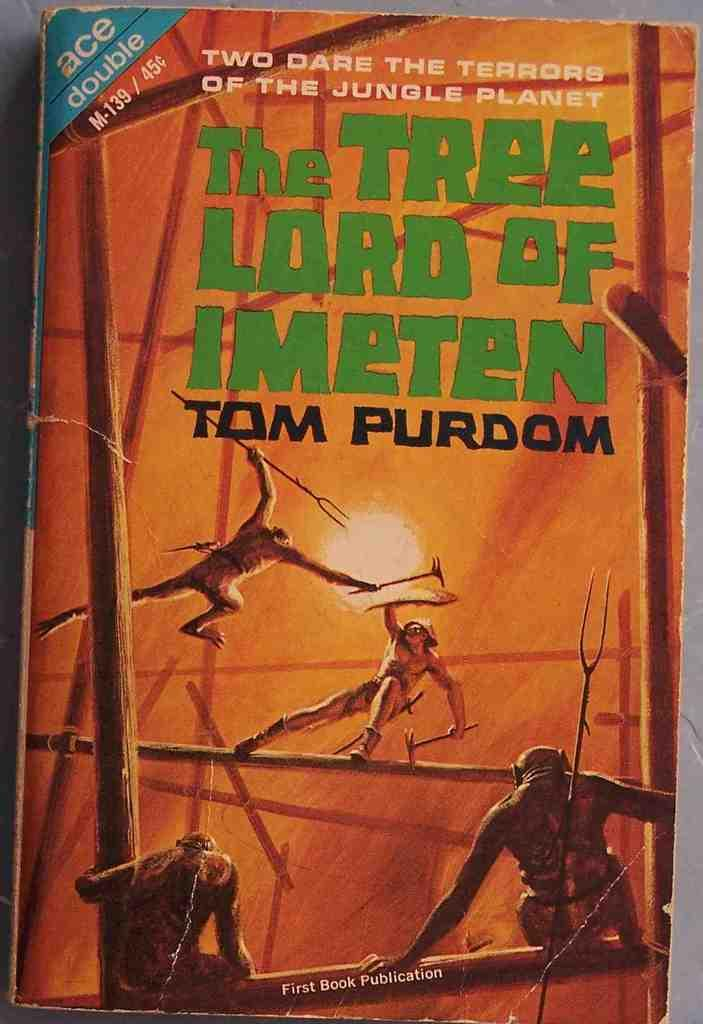<image>
Present a compact description of the photo's key features. A book by Tom Purdom shows people fighting with spears on the cover. 